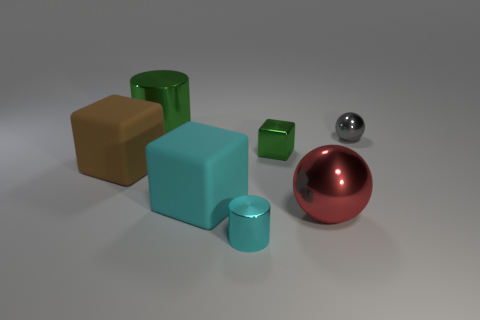What number of matte things are either big cylinders or red balls?
Provide a succinct answer. 0. What number of rubber things are to the left of the big cylinder?
Offer a terse response. 1. Is there a blue metal ball that has the same size as the metal block?
Keep it short and to the point. No. Is there a cylinder of the same color as the metallic cube?
Offer a terse response. Yes. How many small metallic things have the same color as the big metal cylinder?
Offer a very short reply. 1. Do the small sphere and the shiny cylinder that is behind the large cyan block have the same color?
Ensure brevity in your answer.  No. What number of things are gray matte cylinders or objects that are on the right side of the cyan metal thing?
Make the answer very short. 3. There is a green thing that is on the right side of the cylinder that is in front of the green shiny cube; how big is it?
Keep it short and to the point. Small. Are there the same number of red things that are right of the small green metallic object and small gray things that are behind the large cylinder?
Offer a terse response. No. There is a large rubber cube left of the green cylinder; are there any small gray metal spheres to the left of it?
Provide a succinct answer. No. 